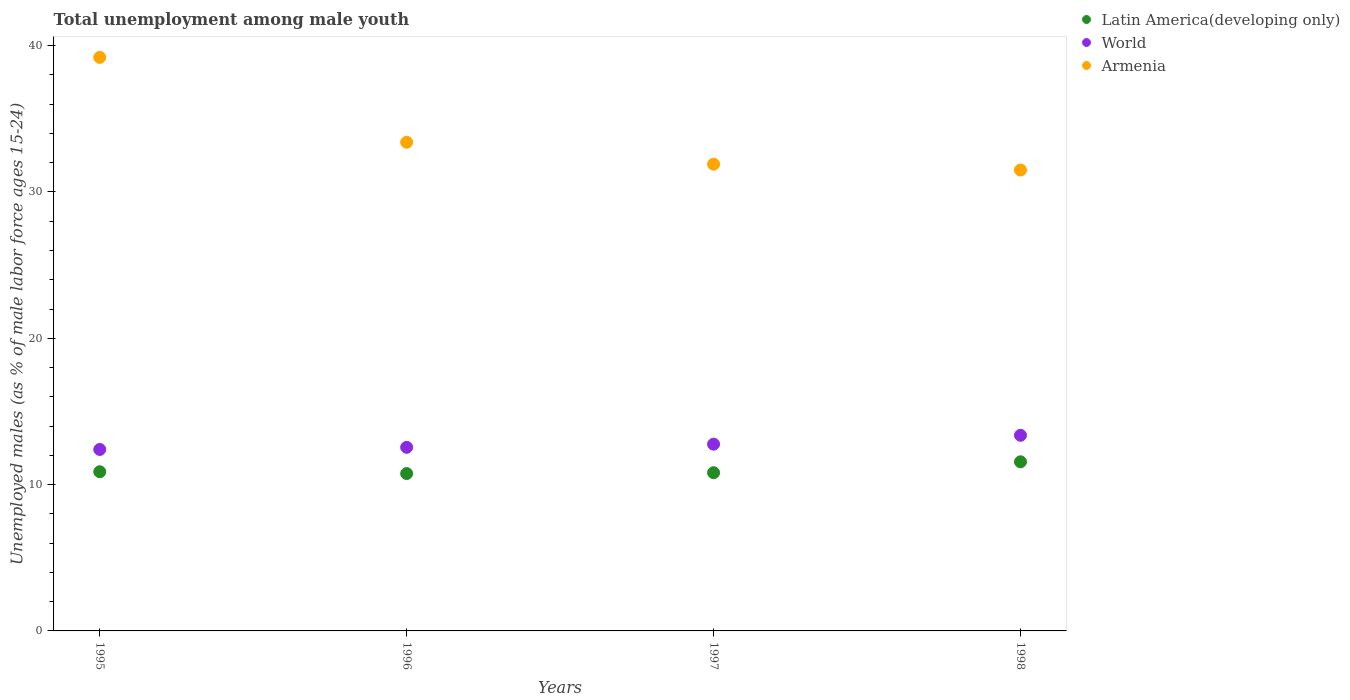How many different coloured dotlines are there?
Give a very brief answer. 3. Is the number of dotlines equal to the number of legend labels?
Give a very brief answer. Yes. What is the percentage of unemployed males in in World in 1998?
Ensure brevity in your answer.  13.37. Across all years, what is the maximum percentage of unemployed males in in Latin America(developing only)?
Your response must be concise. 11.56. Across all years, what is the minimum percentage of unemployed males in in Latin America(developing only)?
Your response must be concise. 10.76. In which year was the percentage of unemployed males in in World maximum?
Give a very brief answer. 1998. What is the total percentage of unemployed males in in Armenia in the graph?
Your answer should be compact. 136. What is the difference between the percentage of unemployed males in in Armenia in 1995 and that in 1996?
Make the answer very short. 5.8. What is the difference between the percentage of unemployed males in in Latin America(developing only) in 1997 and the percentage of unemployed males in in World in 1996?
Make the answer very short. -1.74. What is the average percentage of unemployed males in in Latin America(developing only) per year?
Give a very brief answer. 11. In the year 1995, what is the difference between the percentage of unemployed males in in World and percentage of unemployed males in in Armenia?
Your answer should be very brief. -26.8. In how many years, is the percentage of unemployed males in in Latin America(developing only) greater than 4 %?
Your response must be concise. 4. What is the ratio of the percentage of unemployed males in in Armenia in 1996 to that in 1997?
Provide a succinct answer. 1.05. Is the percentage of unemployed males in in Armenia in 1996 less than that in 1998?
Give a very brief answer. No. Is the difference between the percentage of unemployed males in in World in 1995 and 1996 greater than the difference between the percentage of unemployed males in in Armenia in 1995 and 1996?
Keep it short and to the point. No. What is the difference between the highest and the second highest percentage of unemployed males in in Latin America(developing only)?
Make the answer very short. 0.68. What is the difference between the highest and the lowest percentage of unemployed males in in Armenia?
Your answer should be very brief. 7.7. In how many years, is the percentage of unemployed males in in Latin America(developing only) greater than the average percentage of unemployed males in in Latin America(developing only) taken over all years?
Ensure brevity in your answer.  1. Is it the case that in every year, the sum of the percentage of unemployed males in in Latin America(developing only) and percentage of unemployed males in in Armenia  is greater than the percentage of unemployed males in in World?
Your response must be concise. Yes. Does the percentage of unemployed males in in Armenia monotonically increase over the years?
Make the answer very short. No. Is the percentage of unemployed males in in World strictly less than the percentage of unemployed males in in Latin America(developing only) over the years?
Make the answer very short. No. How many dotlines are there?
Your response must be concise. 3. How many years are there in the graph?
Your answer should be compact. 4. What is the difference between two consecutive major ticks on the Y-axis?
Give a very brief answer. 10. Are the values on the major ticks of Y-axis written in scientific E-notation?
Offer a very short reply. No. Does the graph contain grids?
Provide a short and direct response. No. Where does the legend appear in the graph?
Provide a succinct answer. Top right. How many legend labels are there?
Provide a short and direct response. 3. How are the legend labels stacked?
Offer a terse response. Vertical. What is the title of the graph?
Your answer should be very brief. Total unemployment among male youth. What is the label or title of the Y-axis?
Make the answer very short. Unemployed males (as % of male labor force ages 15-24). What is the Unemployed males (as % of male labor force ages 15-24) in Latin America(developing only) in 1995?
Offer a very short reply. 10.88. What is the Unemployed males (as % of male labor force ages 15-24) in World in 1995?
Your answer should be compact. 12.4. What is the Unemployed males (as % of male labor force ages 15-24) of Armenia in 1995?
Your answer should be compact. 39.2. What is the Unemployed males (as % of male labor force ages 15-24) in Latin America(developing only) in 1996?
Make the answer very short. 10.76. What is the Unemployed males (as % of male labor force ages 15-24) of World in 1996?
Provide a succinct answer. 12.55. What is the Unemployed males (as % of male labor force ages 15-24) in Armenia in 1996?
Offer a very short reply. 33.4. What is the Unemployed males (as % of male labor force ages 15-24) of Latin America(developing only) in 1997?
Give a very brief answer. 10.81. What is the Unemployed males (as % of male labor force ages 15-24) of World in 1997?
Keep it short and to the point. 12.76. What is the Unemployed males (as % of male labor force ages 15-24) of Armenia in 1997?
Ensure brevity in your answer.  31.9. What is the Unemployed males (as % of male labor force ages 15-24) of Latin America(developing only) in 1998?
Ensure brevity in your answer.  11.56. What is the Unemployed males (as % of male labor force ages 15-24) of World in 1998?
Your answer should be very brief. 13.37. What is the Unemployed males (as % of male labor force ages 15-24) of Armenia in 1998?
Give a very brief answer. 31.5. Across all years, what is the maximum Unemployed males (as % of male labor force ages 15-24) in Latin America(developing only)?
Offer a terse response. 11.56. Across all years, what is the maximum Unemployed males (as % of male labor force ages 15-24) of World?
Provide a succinct answer. 13.37. Across all years, what is the maximum Unemployed males (as % of male labor force ages 15-24) of Armenia?
Your answer should be very brief. 39.2. Across all years, what is the minimum Unemployed males (as % of male labor force ages 15-24) of Latin America(developing only)?
Give a very brief answer. 10.76. Across all years, what is the minimum Unemployed males (as % of male labor force ages 15-24) in World?
Give a very brief answer. 12.4. Across all years, what is the minimum Unemployed males (as % of male labor force ages 15-24) of Armenia?
Ensure brevity in your answer.  31.5. What is the total Unemployed males (as % of male labor force ages 15-24) in Latin America(developing only) in the graph?
Offer a terse response. 44.01. What is the total Unemployed males (as % of male labor force ages 15-24) in World in the graph?
Provide a succinct answer. 51.09. What is the total Unemployed males (as % of male labor force ages 15-24) of Armenia in the graph?
Your response must be concise. 136. What is the difference between the Unemployed males (as % of male labor force ages 15-24) in Latin America(developing only) in 1995 and that in 1996?
Your response must be concise. 0.12. What is the difference between the Unemployed males (as % of male labor force ages 15-24) of World in 1995 and that in 1996?
Your answer should be compact. -0.15. What is the difference between the Unemployed males (as % of male labor force ages 15-24) of Armenia in 1995 and that in 1996?
Offer a very short reply. 5.8. What is the difference between the Unemployed males (as % of male labor force ages 15-24) of Latin America(developing only) in 1995 and that in 1997?
Your answer should be very brief. 0.07. What is the difference between the Unemployed males (as % of male labor force ages 15-24) of World in 1995 and that in 1997?
Give a very brief answer. -0.36. What is the difference between the Unemployed males (as % of male labor force ages 15-24) in Armenia in 1995 and that in 1997?
Offer a very short reply. 7.3. What is the difference between the Unemployed males (as % of male labor force ages 15-24) in Latin America(developing only) in 1995 and that in 1998?
Ensure brevity in your answer.  -0.68. What is the difference between the Unemployed males (as % of male labor force ages 15-24) in World in 1995 and that in 1998?
Provide a succinct answer. -0.97. What is the difference between the Unemployed males (as % of male labor force ages 15-24) of Armenia in 1995 and that in 1998?
Make the answer very short. 7.7. What is the difference between the Unemployed males (as % of male labor force ages 15-24) of Latin America(developing only) in 1996 and that in 1997?
Offer a very short reply. -0.06. What is the difference between the Unemployed males (as % of male labor force ages 15-24) in World in 1996 and that in 1997?
Provide a short and direct response. -0.22. What is the difference between the Unemployed males (as % of male labor force ages 15-24) of Latin America(developing only) in 1996 and that in 1998?
Make the answer very short. -0.8. What is the difference between the Unemployed males (as % of male labor force ages 15-24) of World in 1996 and that in 1998?
Provide a succinct answer. -0.82. What is the difference between the Unemployed males (as % of male labor force ages 15-24) in Armenia in 1996 and that in 1998?
Ensure brevity in your answer.  1.9. What is the difference between the Unemployed males (as % of male labor force ages 15-24) in Latin America(developing only) in 1997 and that in 1998?
Offer a terse response. -0.75. What is the difference between the Unemployed males (as % of male labor force ages 15-24) of World in 1997 and that in 1998?
Ensure brevity in your answer.  -0.61. What is the difference between the Unemployed males (as % of male labor force ages 15-24) of Armenia in 1997 and that in 1998?
Your answer should be very brief. 0.4. What is the difference between the Unemployed males (as % of male labor force ages 15-24) in Latin America(developing only) in 1995 and the Unemployed males (as % of male labor force ages 15-24) in World in 1996?
Your answer should be very brief. -1.67. What is the difference between the Unemployed males (as % of male labor force ages 15-24) in Latin America(developing only) in 1995 and the Unemployed males (as % of male labor force ages 15-24) in Armenia in 1996?
Provide a succinct answer. -22.52. What is the difference between the Unemployed males (as % of male labor force ages 15-24) in World in 1995 and the Unemployed males (as % of male labor force ages 15-24) in Armenia in 1996?
Make the answer very short. -21. What is the difference between the Unemployed males (as % of male labor force ages 15-24) of Latin America(developing only) in 1995 and the Unemployed males (as % of male labor force ages 15-24) of World in 1997?
Provide a short and direct response. -1.88. What is the difference between the Unemployed males (as % of male labor force ages 15-24) of Latin America(developing only) in 1995 and the Unemployed males (as % of male labor force ages 15-24) of Armenia in 1997?
Keep it short and to the point. -21.02. What is the difference between the Unemployed males (as % of male labor force ages 15-24) in World in 1995 and the Unemployed males (as % of male labor force ages 15-24) in Armenia in 1997?
Provide a short and direct response. -19.5. What is the difference between the Unemployed males (as % of male labor force ages 15-24) of Latin America(developing only) in 1995 and the Unemployed males (as % of male labor force ages 15-24) of World in 1998?
Make the answer very short. -2.49. What is the difference between the Unemployed males (as % of male labor force ages 15-24) of Latin America(developing only) in 1995 and the Unemployed males (as % of male labor force ages 15-24) of Armenia in 1998?
Keep it short and to the point. -20.62. What is the difference between the Unemployed males (as % of male labor force ages 15-24) in World in 1995 and the Unemployed males (as % of male labor force ages 15-24) in Armenia in 1998?
Provide a short and direct response. -19.1. What is the difference between the Unemployed males (as % of male labor force ages 15-24) in Latin America(developing only) in 1996 and the Unemployed males (as % of male labor force ages 15-24) in World in 1997?
Your answer should be very brief. -2.01. What is the difference between the Unemployed males (as % of male labor force ages 15-24) in Latin America(developing only) in 1996 and the Unemployed males (as % of male labor force ages 15-24) in Armenia in 1997?
Keep it short and to the point. -21.14. What is the difference between the Unemployed males (as % of male labor force ages 15-24) in World in 1996 and the Unemployed males (as % of male labor force ages 15-24) in Armenia in 1997?
Your response must be concise. -19.35. What is the difference between the Unemployed males (as % of male labor force ages 15-24) in Latin America(developing only) in 1996 and the Unemployed males (as % of male labor force ages 15-24) in World in 1998?
Your answer should be very brief. -2.61. What is the difference between the Unemployed males (as % of male labor force ages 15-24) of Latin America(developing only) in 1996 and the Unemployed males (as % of male labor force ages 15-24) of Armenia in 1998?
Keep it short and to the point. -20.74. What is the difference between the Unemployed males (as % of male labor force ages 15-24) in World in 1996 and the Unemployed males (as % of male labor force ages 15-24) in Armenia in 1998?
Your response must be concise. -18.95. What is the difference between the Unemployed males (as % of male labor force ages 15-24) in Latin America(developing only) in 1997 and the Unemployed males (as % of male labor force ages 15-24) in World in 1998?
Your response must be concise. -2.56. What is the difference between the Unemployed males (as % of male labor force ages 15-24) of Latin America(developing only) in 1997 and the Unemployed males (as % of male labor force ages 15-24) of Armenia in 1998?
Ensure brevity in your answer.  -20.69. What is the difference between the Unemployed males (as % of male labor force ages 15-24) of World in 1997 and the Unemployed males (as % of male labor force ages 15-24) of Armenia in 1998?
Give a very brief answer. -18.74. What is the average Unemployed males (as % of male labor force ages 15-24) in Latin America(developing only) per year?
Offer a terse response. 11. What is the average Unemployed males (as % of male labor force ages 15-24) in World per year?
Your answer should be compact. 12.77. In the year 1995, what is the difference between the Unemployed males (as % of male labor force ages 15-24) of Latin America(developing only) and Unemployed males (as % of male labor force ages 15-24) of World?
Your answer should be compact. -1.52. In the year 1995, what is the difference between the Unemployed males (as % of male labor force ages 15-24) of Latin America(developing only) and Unemployed males (as % of male labor force ages 15-24) of Armenia?
Your answer should be very brief. -28.32. In the year 1995, what is the difference between the Unemployed males (as % of male labor force ages 15-24) of World and Unemployed males (as % of male labor force ages 15-24) of Armenia?
Your answer should be compact. -26.8. In the year 1996, what is the difference between the Unemployed males (as % of male labor force ages 15-24) of Latin America(developing only) and Unemployed males (as % of male labor force ages 15-24) of World?
Your response must be concise. -1.79. In the year 1996, what is the difference between the Unemployed males (as % of male labor force ages 15-24) in Latin America(developing only) and Unemployed males (as % of male labor force ages 15-24) in Armenia?
Ensure brevity in your answer.  -22.64. In the year 1996, what is the difference between the Unemployed males (as % of male labor force ages 15-24) in World and Unemployed males (as % of male labor force ages 15-24) in Armenia?
Make the answer very short. -20.85. In the year 1997, what is the difference between the Unemployed males (as % of male labor force ages 15-24) of Latin America(developing only) and Unemployed males (as % of male labor force ages 15-24) of World?
Offer a terse response. -1.95. In the year 1997, what is the difference between the Unemployed males (as % of male labor force ages 15-24) in Latin America(developing only) and Unemployed males (as % of male labor force ages 15-24) in Armenia?
Ensure brevity in your answer.  -21.09. In the year 1997, what is the difference between the Unemployed males (as % of male labor force ages 15-24) in World and Unemployed males (as % of male labor force ages 15-24) in Armenia?
Your answer should be compact. -19.14. In the year 1998, what is the difference between the Unemployed males (as % of male labor force ages 15-24) of Latin America(developing only) and Unemployed males (as % of male labor force ages 15-24) of World?
Make the answer very short. -1.81. In the year 1998, what is the difference between the Unemployed males (as % of male labor force ages 15-24) of Latin America(developing only) and Unemployed males (as % of male labor force ages 15-24) of Armenia?
Offer a terse response. -19.94. In the year 1998, what is the difference between the Unemployed males (as % of male labor force ages 15-24) in World and Unemployed males (as % of male labor force ages 15-24) in Armenia?
Your answer should be very brief. -18.13. What is the ratio of the Unemployed males (as % of male labor force ages 15-24) of Latin America(developing only) in 1995 to that in 1996?
Make the answer very short. 1.01. What is the ratio of the Unemployed males (as % of male labor force ages 15-24) in World in 1995 to that in 1996?
Your answer should be very brief. 0.99. What is the ratio of the Unemployed males (as % of male labor force ages 15-24) of Armenia in 1995 to that in 1996?
Offer a very short reply. 1.17. What is the ratio of the Unemployed males (as % of male labor force ages 15-24) in Latin America(developing only) in 1995 to that in 1997?
Give a very brief answer. 1.01. What is the ratio of the Unemployed males (as % of male labor force ages 15-24) in World in 1995 to that in 1997?
Your response must be concise. 0.97. What is the ratio of the Unemployed males (as % of male labor force ages 15-24) of Armenia in 1995 to that in 1997?
Provide a short and direct response. 1.23. What is the ratio of the Unemployed males (as % of male labor force ages 15-24) of Latin America(developing only) in 1995 to that in 1998?
Your answer should be very brief. 0.94. What is the ratio of the Unemployed males (as % of male labor force ages 15-24) in World in 1995 to that in 1998?
Provide a short and direct response. 0.93. What is the ratio of the Unemployed males (as % of male labor force ages 15-24) in Armenia in 1995 to that in 1998?
Offer a terse response. 1.24. What is the ratio of the Unemployed males (as % of male labor force ages 15-24) in World in 1996 to that in 1997?
Ensure brevity in your answer.  0.98. What is the ratio of the Unemployed males (as % of male labor force ages 15-24) of Armenia in 1996 to that in 1997?
Your answer should be very brief. 1.05. What is the ratio of the Unemployed males (as % of male labor force ages 15-24) in Latin America(developing only) in 1996 to that in 1998?
Give a very brief answer. 0.93. What is the ratio of the Unemployed males (as % of male labor force ages 15-24) of World in 1996 to that in 1998?
Offer a very short reply. 0.94. What is the ratio of the Unemployed males (as % of male labor force ages 15-24) in Armenia in 1996 to that in 1998?
Offer a very short reply. 1.06. What is the ratio of the Unemployed males (as % of male labor force ages 15-24) in Latin America(developing only) in 1997 to that in 1998?
Offer a terse response. 0.94. What is the ratio of the Unemployed males (as % of male labor force ages 15-24) of World in 1997 to that in 1998?
Keep it short and to the point. 0.95. What is the ratio of the Unemployed males (as % of male labor force ages 15-24) of Armenia in 1997 to that in 1998?
Provide a succinct answer. 1.01. What is the difference between the highest and the second highest Unemployed males (as % of male labor force ages 15-24) in Latin America(developing only)?
Make the answer very short. 0.68. What is the difference between the highest and the second highest Unemployed males (as % of male labor force ages 15-24) in World?
Your answer should be very brief. 0.61. What is the difference between the highest and the second highest Unemployed males (as % of male labor force ages 15-24) of Armenia?
Your answer should be compact. 5.8. What is the difference between the highest and the lowest Unemployed males (as % of male labor force ages 15-24) of Latin America(developing only)?
Provide a short and direct response. 0.8. What is the difference between the highest and the lowest Unemployed males (as % of male labor force ages 15-24) of World?
Your response must be concise. 0.97. 